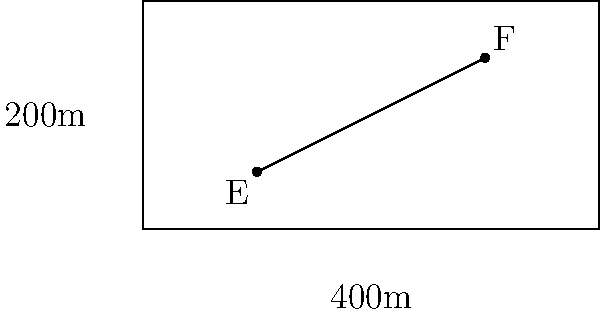A speed skater completes one lap around the oval track shown above in 30 seconds. If the track dimensions were to be increased by 10% in both length and width, approximately how long would it take the skater to complete one lap, assuming they maintain the same speed? Let's approach this step-by-step:

1) First, we need to calculate the current track length:
   Current length = $2 \times (400 + 200) = 1200$ meters

2) If the dimensions are increased by 10%, the new track dimensions would be:
   New length = $400 \times 1.1 = 440$ meters
   New width = $200 \times 1.1 = 220$ meters

3) The new track length would be:
   New total length = $2 \times (440 + 220) = 1320$ meters

4) To calculate the new lap time, we can use the proportion:
   $\frac{\text{Old Distance}}{\text{Old Time}} = \frac{\text{New Distance}}{\text{New Time}}$

5) Plugging in the values:
   $\frac{1200}{30} = \frac{1320}{x}$

6) Solving for $x$:
   $x = \frac{1320 \times 30}{1200} = 33$ seconds

Therefore, it would take the skater approximately 33 seconds to complete one lap on the enlarged track.
Answer: 33 seconds 